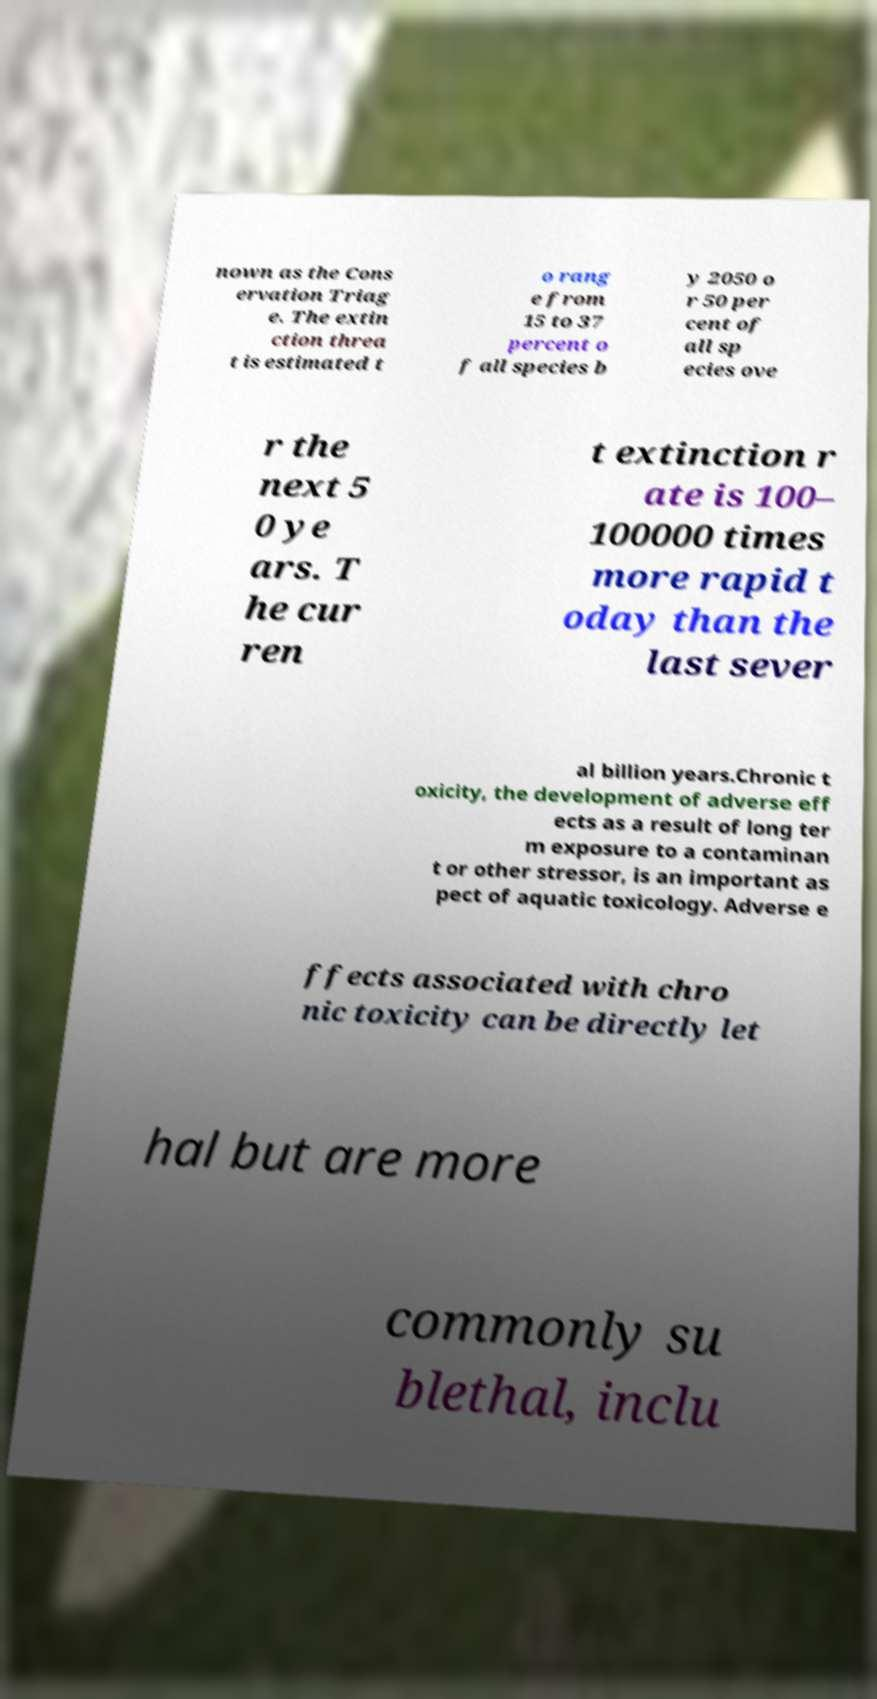For documentation purposes, I need the text within this image transcribed. Could you provide that? nown as the Cons ervation Triag e. The extin ction threa t is estimated t o rang e from 15 to 37 percent o f all species b y 2050 o r 50 per cent of all sp ecies ove r the next 5 0 ye ars. T he cur ren t extinction r ate is 100– 100000 times more rapid t oday than the last sever al billion years.Chronic t oxicity, the development of adverse eff ects as a result of long ter m exposure to a contaminan t or other stressor, is an important as pect of aquatic toxicology. Adverse e ffects associated with chro nic toxicity can be directly let hal but are more commonly su blethal, inclu 